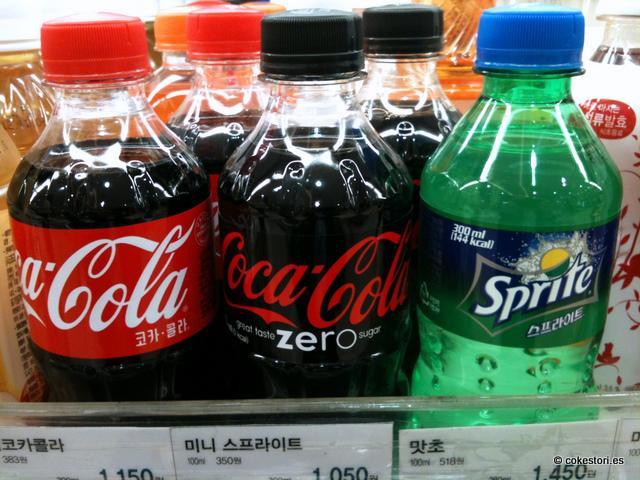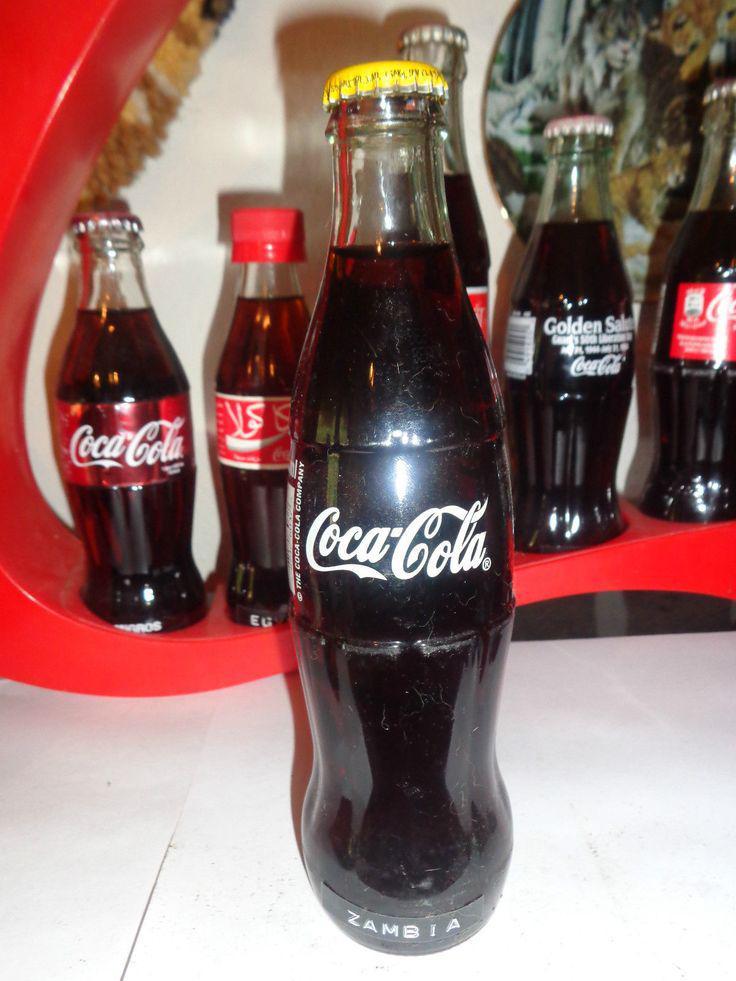The first image is the image on the left, the second image is the image on the right. Analyze the images presented: Is the assertion "Two bottles are standing in front of all the others." valid? Answer yes or no. No. The first image is the image on the left, the second image is the image on the right. Given the left and right images, does the statement "The front most bottle in each of the images has a similarly colored label." hold true? Answer yes or no. No. 